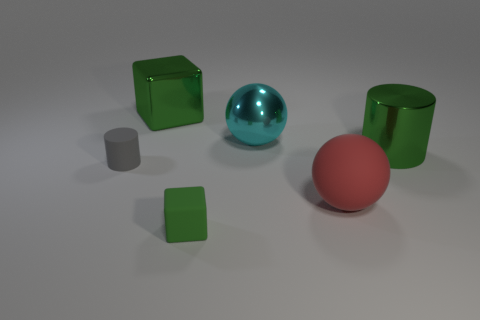Add 1 tiny gray things. How many objects exist? 7 Subtract all blocks. How many objects are left? 4 Subtract 0 blue balls. How many objects are left? 6 Subtract all large red rubber blocks. Subtract all green matte cubes. How many objects are left? 5 Add 2 green cylinders. How many green cylinders are left? 3 Add 6 green shiny cubes. How many green shiny cubes exist? 7 